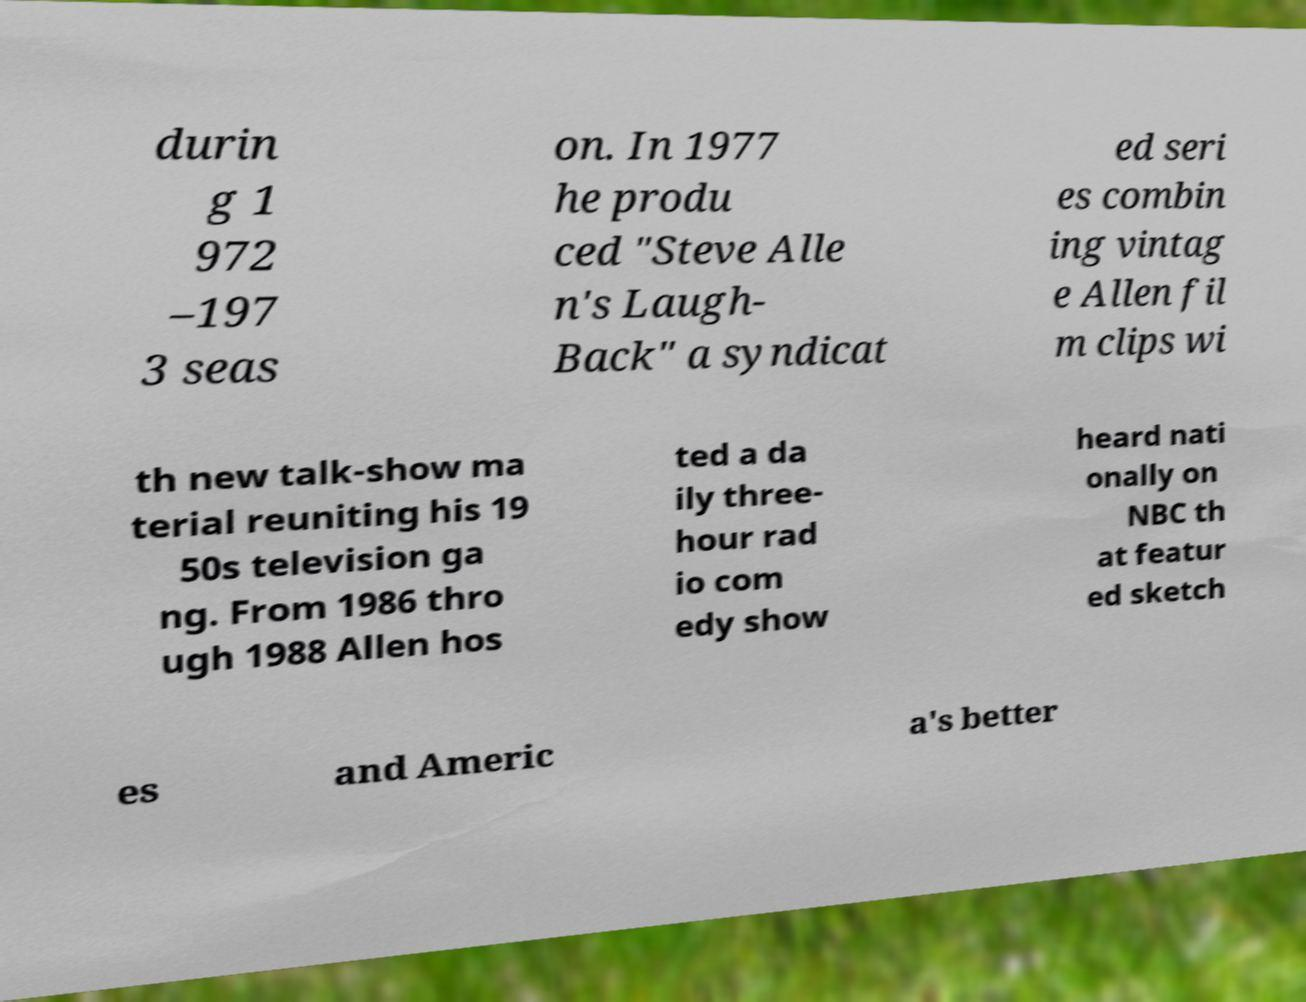For documentation purposes, I need the text within this image transcribed. Could you provide that? durin g 1 972 –197 3 seas on. In 1977 he produ ced "Steve Alle n's Laugh- Back" a syndicat ed seri es combin ing vintag e Allen fil m clips wi th new talk-show ma terial reuniting his 19 50s television ga ng. From 1986 thro ugh 1988 Allen hos ted a da ily three- hour rad io com edy show heard nati onally on NBC th at featur ed sketch es and Americ a's better 